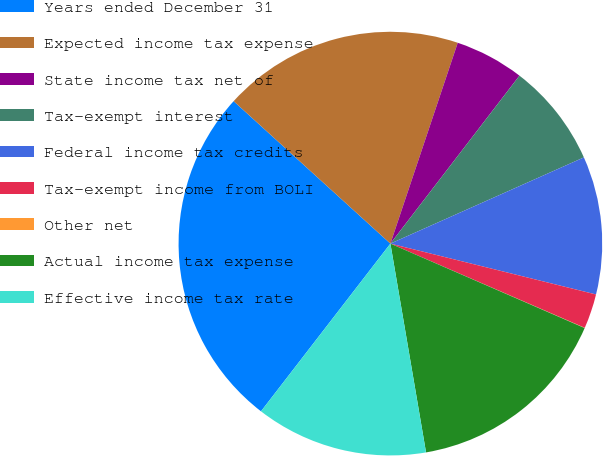Convert chart. <chart><loc_0><loc_0><loc_500><loc_500><pie_chart><fcel>Years ended December 31<fcel>Expected income tax expense<fcel>State income tax net of<fcel>Tax-exempt interest<fcel>Federal income tax credits<fcel>Tax-exempt income from BOLI<fcel>Other net<fcel>Actual income tax expense<fcel>Effective income tax rate<nl><fcel>26.28%<fcel>18.41%<fcel>5.28%<fcel>7.9%<fcel>10.53%<fcel>2.65%<fcel>0.02%<fcel>15.78%<fcel>13.15%<nl></chart> 